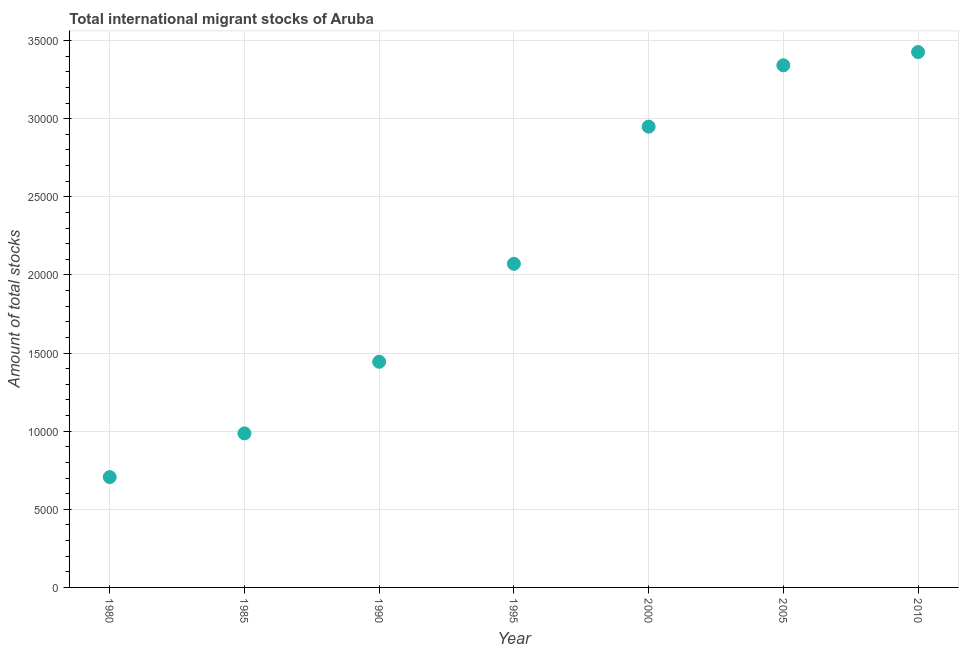What is the total number of international migrant stock in 1990?
Your response must be concise. 1.44e+04. Across all years, what is the maximum total number of international migrant stock?
Your answer should be compact. 3.43e+04. Across all years, what is the minimum total number of international migrant stock?
Give a very brief answer. 7063. In which year was the total number of international migrant stock minimum?
Offer a very short reply. 1980. What is the sum of the total number of international migrant stock?
Make the answer very short. 1.49e+05. What is the difference between the total number of international migrant stock in 1985 and 2005?
Make the answer very short. -2.36e+04. What is the average total number of international migrant stock per year?
Your response must be concise. 2.13e+04. What is the median total number of international migrant stock?
Your response must be concise. 2.07e+04. In how many years, is the total number of international migrant stock greater than 4000 ?
Your answer should be very brief. 7. What is the ratio of the total number of international migrant stock in 1985 to that in 1990?
Provide a succinct answer. 0.68. What is the difference between the highest and the second highest total number of international migrant stock?
Keep it short and to the point. 846. Is the sum of the total number of international migrant stock in 1985 and 2000 greater than the maximum total number of international migrant stock across all years?
Your answer should be compact. Yes. What is the difference between the highest and the lowest total number of international migrant stock?
Ensure brevity in your answer.  2.72e+04. How many dotlines are there?
Your response must be concise. 1. Does the graph contain any zero values?
Give a very brief answer. No. What is the title of the graph?
Provide a short and direct response. Total international migrant stocks of Aruba. What is the label or title of the X-axis?
Your answer should be very brief. Year. What is the label or title of the Y-axis?
Make the answer very short. Amount of total stocks. What is the Amount of total stocks in 1980?
Keep it short and to the point. 7063. What is the Amount of total stocks in 1985?
Your response must be concise. 9860. What is the Amount of total stocks in 1990?
Your answer should be very brief. 1.44e+04. What is the Amount of total stocks in 1995?
Provide a short and direct response. 2.07e+04. What is the Amount of total stocks in 2000?
Give a very brief answer. 2.95e+04. What is the Amount of total stocks in 2005?
Your response must be concise. 3.34e+04. What is the Amount of total stocks in 2010?
Your answer should be very brief. 3.43e+04. What is the difference between the Amount of total stocks in 1980 and 1985?
Your response must be concise. -2797. What is the difference between the Amount of total stocks in 1980 and 1990?
Ensure brevity in your answer.  -7381. What is the difference between the Amount of total stocks in 1980 and 1995?
Your answer should be very brief. -1.37e+04. What is the difference between the Amount of total stocks in 1980 and 2000?
Offer a very short reply. -2.24e+04. What is the difference between the Amount of total stocks in 1980 and 2005?
Provide a short and direct response. -2.64e+04. What is the difference between the Amount of total stocks in 1980 and 2010?
Give a very brief answer. -2.72e+04. What is the difference between the Amount of total stocks in 1985 and 1990?
Your response must be concise. -4584. What is the difference between the Amount of total stocks in 1985 and 1995?
Offer a very short reply. -1.09e+04. What is the difference between the Amount of total stocks in 1985 and 2000?
Provide a succinct answer. -1.96e+04. What is the difference between the Amount of total stocks in 1985 and 2005?
Provide a succinct answer. -2.36e+04. What is the difference between the Amount of total stocks in 1985 and 2010?
Provide a short and direct response. -2.44e+04. What is the difference between the Amount of total stocks in 1990 and 1995?
Make the answer very short. -6271. What is the difference between the Amount of total stocks in 1990 and 2000?
Keep it short and to the point. -1.51e+04. What is the difference between the Amount of total stocks in 1990 and 2005?
Provide a short and direct response. -1.90e+04. What is the difference between the Amount of total stocks in 1990 and 2010?
Provide a short and direct response. -1.98e+04. What is the difference between the Amount of total stocks in 1995 and 2000?
Provide a short and direct response. -8780. What is the difference between the Amount of total stocks in 1995 and 2005?
Your answer should be compact. -1.27e+04. What is the difference between the Amount of total stocks in 1995 and 2010?
Give a very brief answer. -1.36e+04. What is the difference between the Amount of total stocks in 2000 and 2005?
Ensure brevity in your answer.  -3927. What is the difference between the Amount of total stocks in 2000 and 2010?
Ensure brevity in your answer.  -4773. What is the difference between the Amount of total stocks in 2005 and 2010?
Offer a terse response. -846. What is the ratio of the Amount of total stocks in 1980 to that in 1985?
Keep it short and to the point. 0.72. What is the ratio of the Amount of total stocks in 1980 to that in 1990?
Keep it short and to the point. 0.49. What is the ratio of the Amount of total stocks in 1980 to that in 1995?
Make the answer very short. 0.34. What is the ratio of the Amount of total stocks in 1980 to that in 2000?
Make the answer very short. 0.24. What is the ratio of the Amount of total stocks in 1980 to that in 2005?
Your answer should be compact. 0.21. What is the ratio of the Amount of total stocks in 1980 to that in 2010?
Your response must be concise. 0.21. What is the ratio of the Amount of total stocks in 1985 to that in 1990?
Your answer should be very brief. 0.68. What is the ratio of the Amount of total stocks in 1985 to that in 1995?
Make the answer very short. 0.48. What is the ratio of the Amount of total stocks in 1985 to that in 2000?
Offer a terse response. 0.33. What is the ratio of the Amount of total stocks in 1985 to that in 2005?
Offer a terse response. 0.29. What is the ratio of the Amount of total stocks in 1985 to that in 2010?
Offer a very short reply. 0.29. What is the ratio of the Amount of total stocks in 1990 to that in 1995?
Offer a very short reply. 0.7. What is the ratio of the Amount of total stocks in 1990 to that in 2000?
Provide a short and direct response. 0.49. What is the ratio of the Amount of total stocks in 1990 to that in 2005?
Offer a very short reply. 0.43. What is the ratio of the Amount of total stocks in 1990 to that in 2010?
Provide a short and direct response. 0.42. What is the ratio of the Amount of total stocks in 1995 to that in 2000?
Give a very brief answer. 0.7. What is the ratio of the Amount of total stocks in 1995 to that in 2005?
Provide a succinct answer. 0.62. What is the ratio of the Amount of total stocks in 1995 to that in 2010?
Ensure brevity in your answer.  0.6. What is the ratio of the Amount of total stocks in 2000 to that in 2005?
Provide a succinct answer. 0.88. What is the ratio of the Amount of total stocks in 2000 to that in 2010?
Ensure brevity in your answer.  0.86. What is the ratio of the Amount of total stocks in 2005 to that in 2010?
Give a very brief answer. 0.97. 